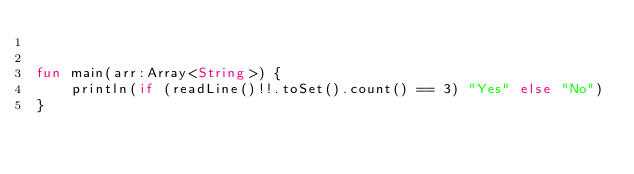Convert code to text. <code><loc_0><loc_0><loc_500><loc_500><_Kotlin_>

fun main(arr:Array<String>) {
    println(if (readLine()!!.toSet().count() == 3) "Yes" else "No")
}

</code> 